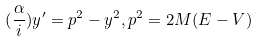Convert formula to latex. <formula><loc_0><loc_0><loc_500><loc_500>( \frac { \alpha } { i } ) y ^ { \prime } = p ^ { 2 } - y ^ { 2 } , p ^ { 2 } = 2 M ( E - V )</formula> 